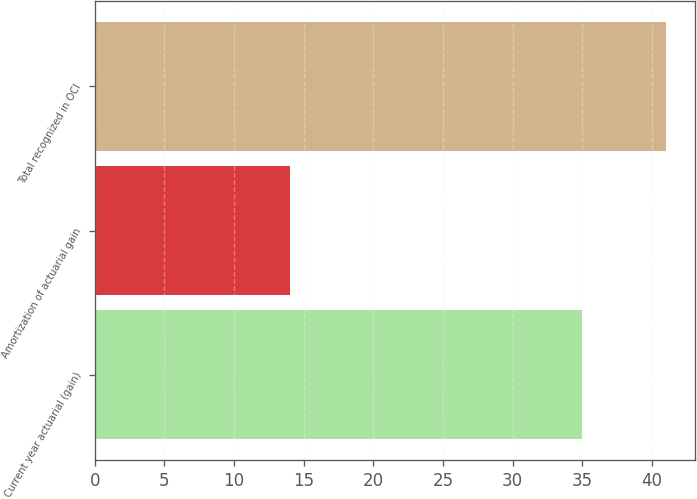Convert chart. <chart><loc_0><loc_0><loc_500><loc_500><bar_chart><fcel>Current year actuarial (gain)<fcel>Amortization of actuarial gain<fcel>Total recognized in OCI<nl><fcel>35<fcel>14<fcel>41<nl></chart> 